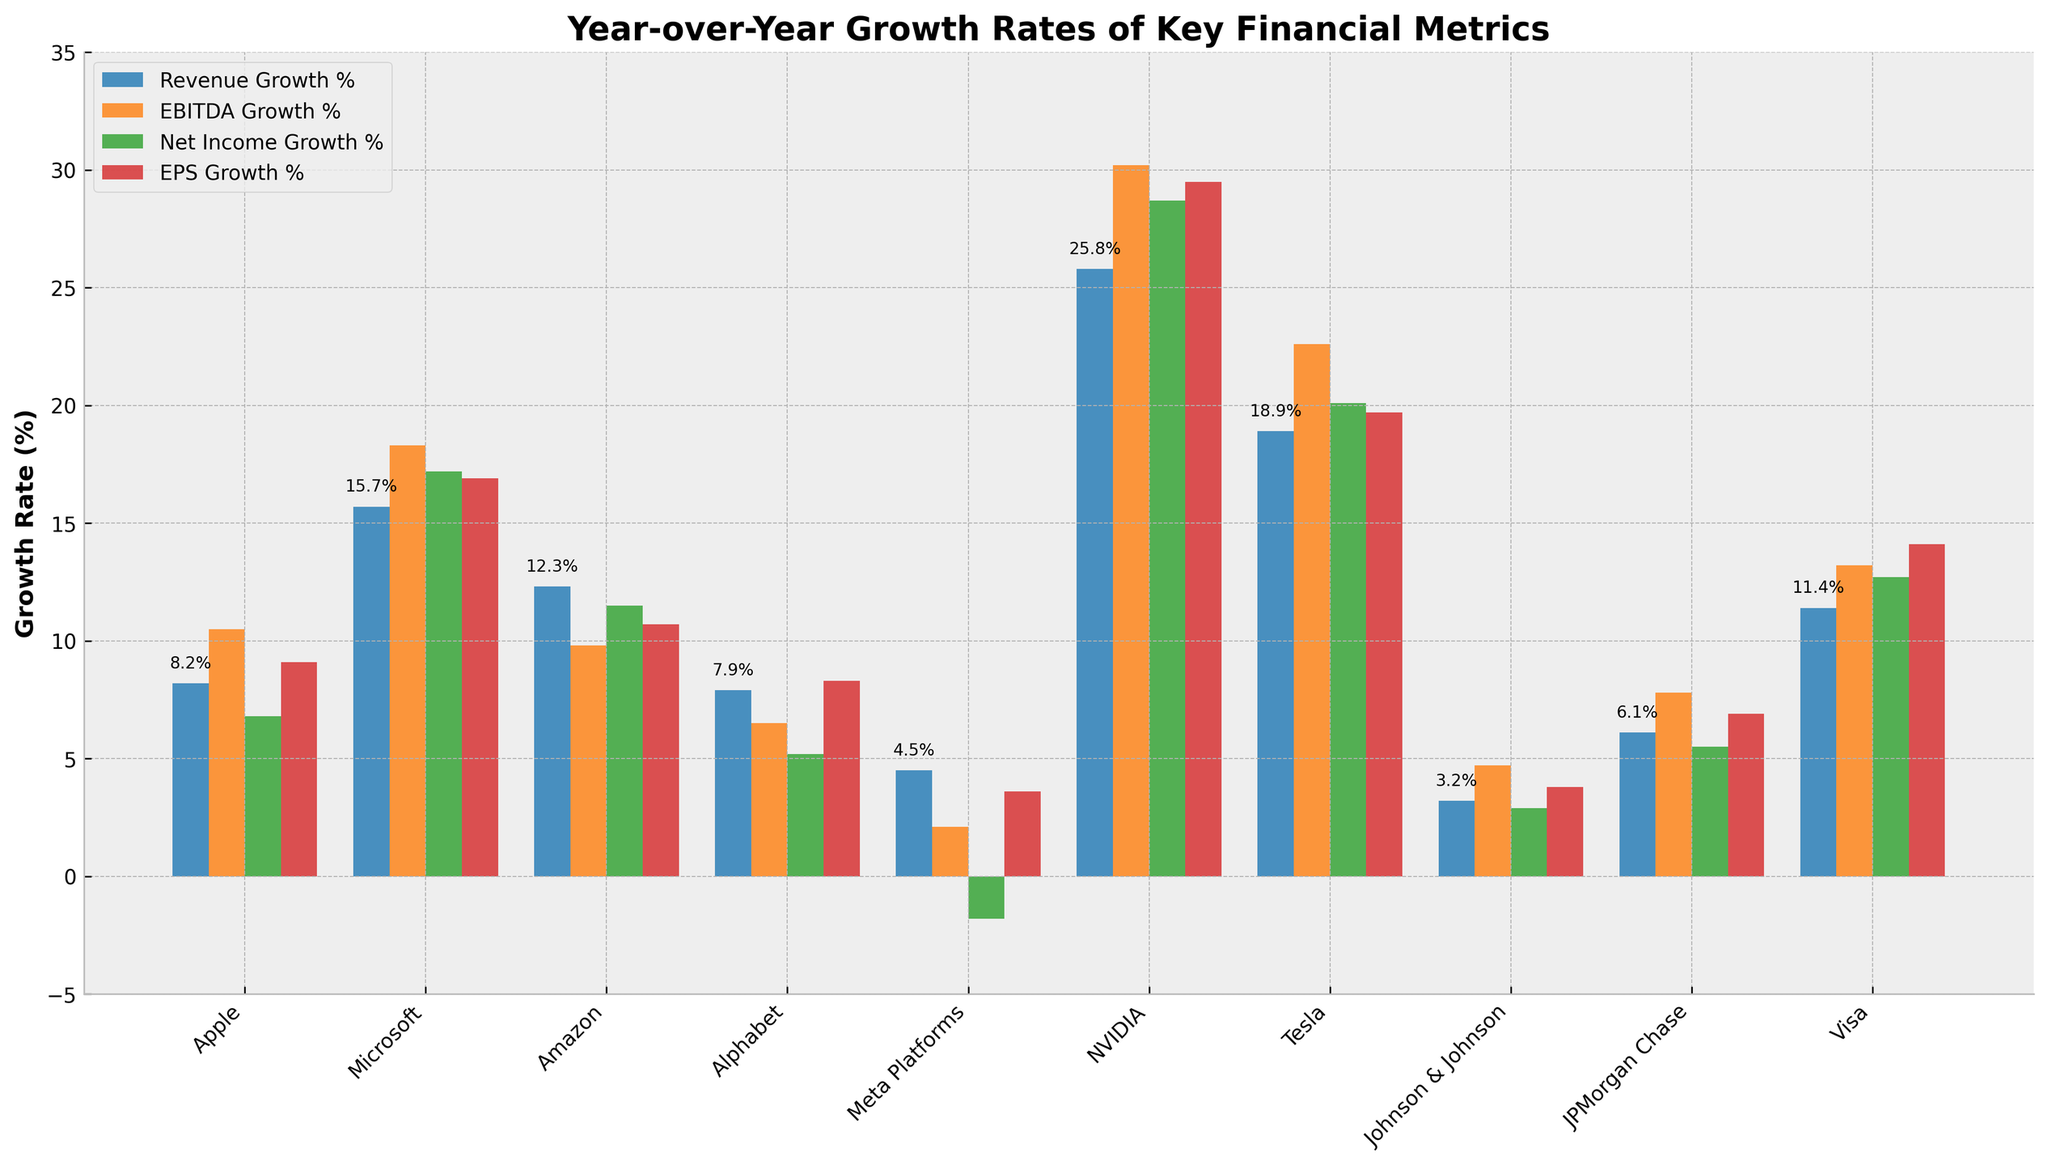what's the company with the highest YoY EPS growth? To find the company with the highest year-over-year EPS growth, we need to identify the bar that represents EPS growth with the maximum height. The EPS Growth % values for each company are: Apple (9.1%), Microsoft (16.9%), Amazon (10.7%), Alphabet (8.3%), Meta Platforms (3.6%), NVIDIA (29.5%), Tesla (19.7%), Johnson & Johnson (3.8%), JPMorgan Chase (6.9%), and Visa (14.1%). Among them, NVIDIA has the highest EPS Growth % at 29.5%.
Answer: NVIDIA How much higher is Tesla's EBITDA Growth % compared to Alphabet's? To determine the difference between Tesla's and Alphabet's EBITDA Growth %, we need the respective values. Tesla's EBITDA Growth % is 22.6% and Alphabet's is 6.5%. Subtract Alphabet's value from Tesla's: 22.6% - 6.5% = 16.1%.
Answer: 16.1% what's the average Revenue Growth % for the listed companies? To calculate the average Revenue Growth %, sum up the Revenue Growth % values for each company and divide by the number of companies. The values are: 8.2 + 15.7 + 12.3 + 7.9 + 4.5 + 25.8 + 18.9 + 3.2 + 6.1 + 11.4. Summing them gives 114.0, and dividing by 10 (the number of companies) results in an average of 11.4%.
Answer: 11.4% Which company has a negative growth for Net Income? To determine which company has a negative Net Income Growth %, look for the bar below zero in the Net Income Growth % series. Meta Platforms has a Net Income Growth % of -1.8%, which is the only negative value.
Answer: Meta Platforms 